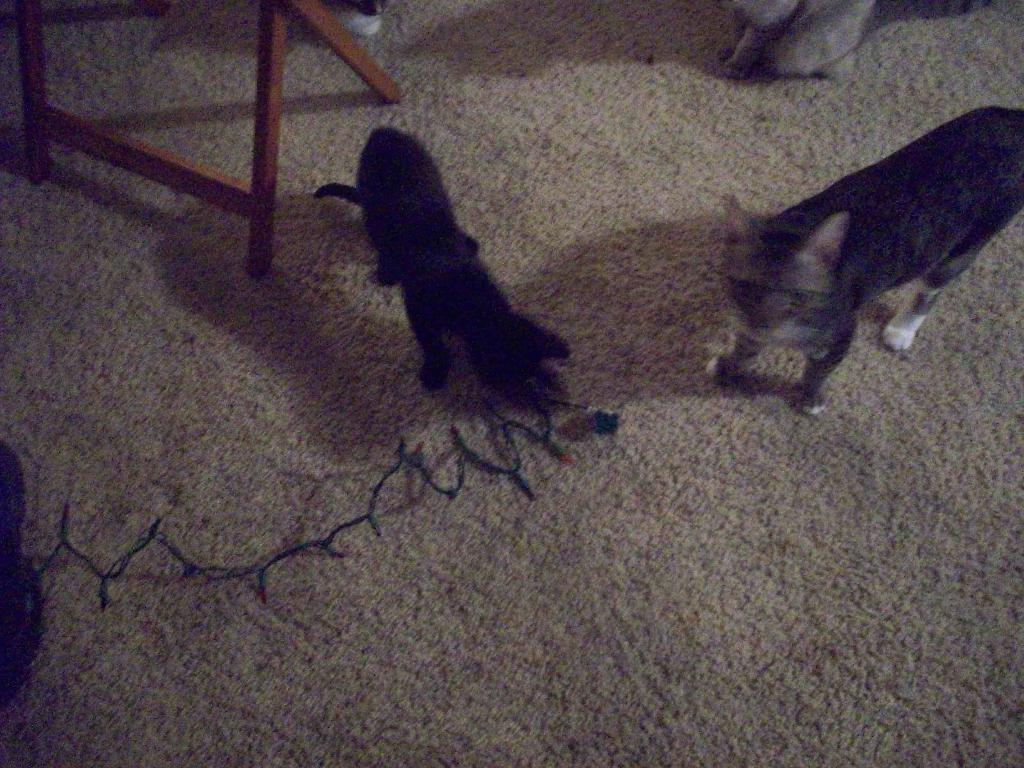What types of living organisms are in the image? There are two animals in the image. Where are the animals located in the image? The animals are on the floor. What type of lighting is present in the image? There are LED lights in the image. What kind of furniture or structure is in the image? There is a wooden stand in the image. Who is the creator of the animals in the image? The image does not provide information about the creator of the animals. What is the reason for the animals being on the floor in the image? The image does not provide information about the reason for the animals being on the floor. 